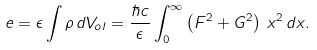<formula> <loc_0><loc_0><loc_500><loc_500>e = \epsilon \int \rho \, d V _ { o l } = \frac { \hbar { c } } { \epsilon } \int _ { 0 } ^ { \infty } \left ( F ^ { 2 } + G ^ { 2 } \right ) \, x ^ { 2 } \, d x .</formula> 